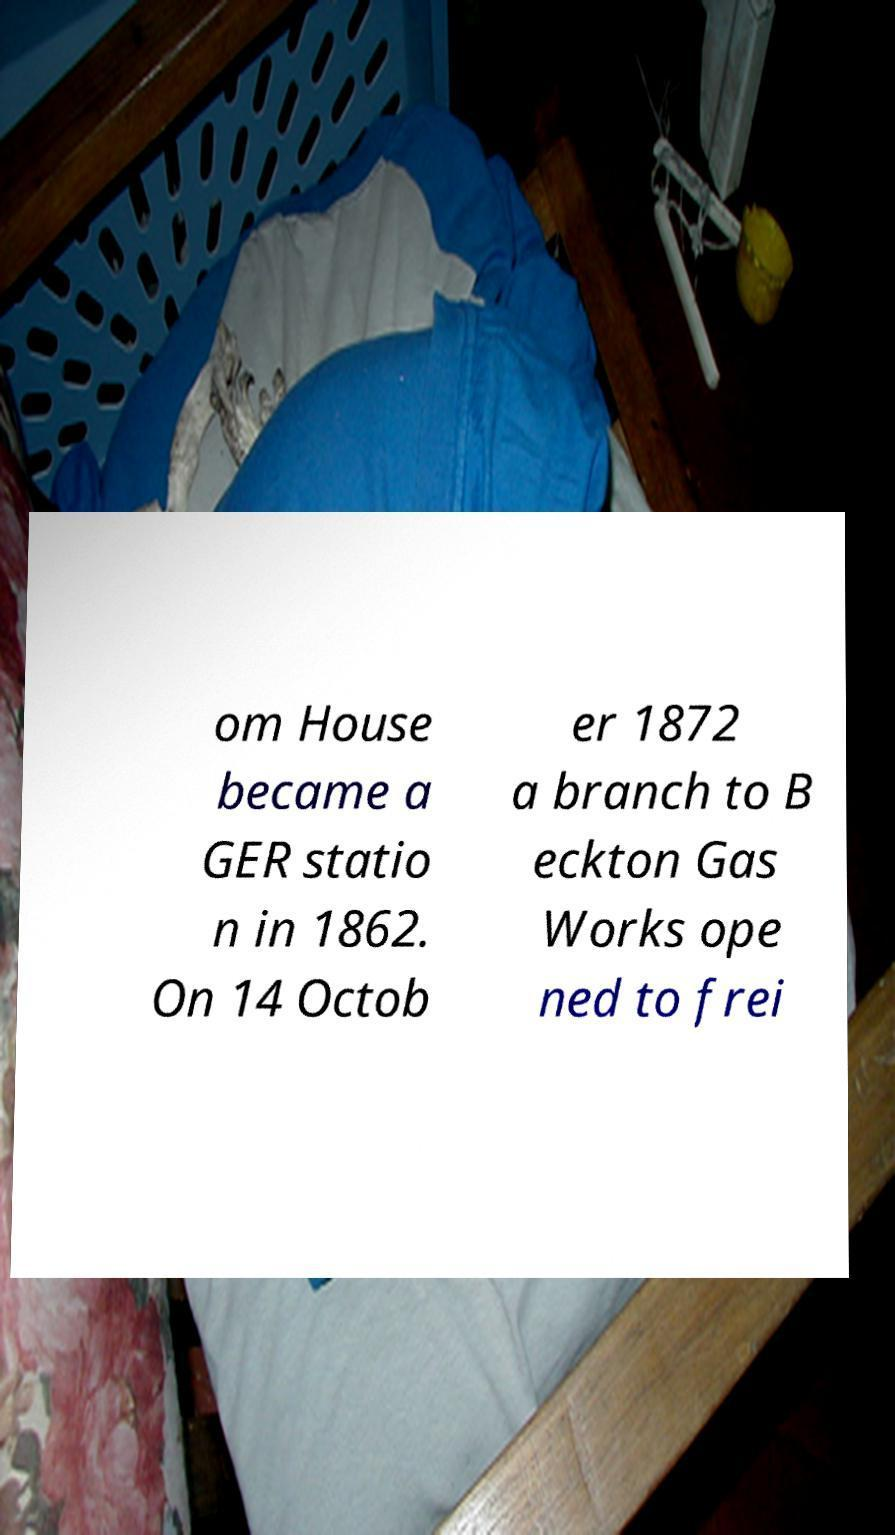Can you accurately transcribe the text from the provided image for me? om House became a GER statio n in 1862. On 14 Octob er 1872 a branch to B eckton Gas Works ope ned to frei 